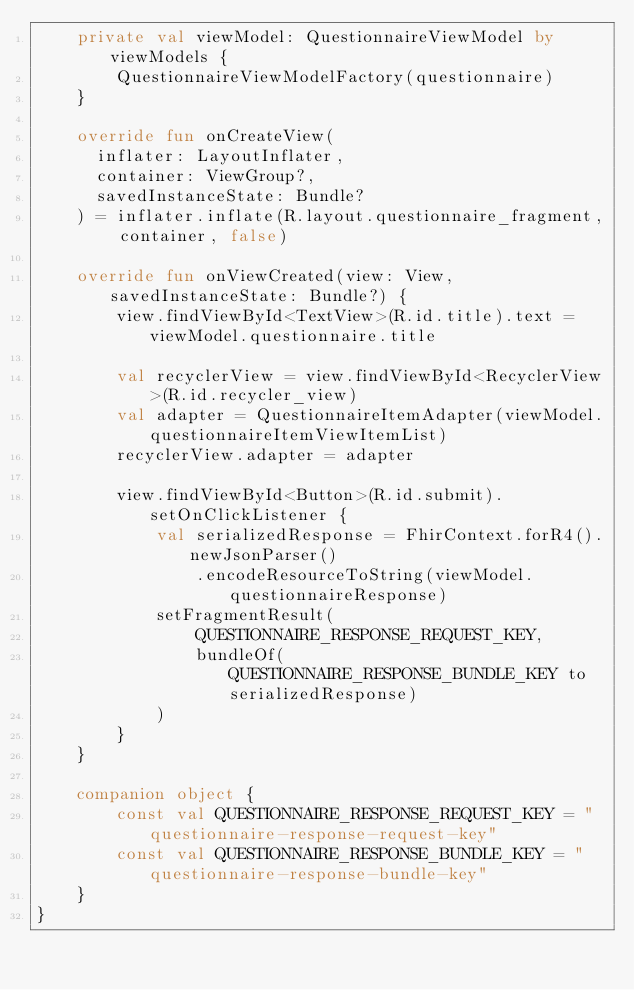Convert code to text. <code><loc_0><loc_0><loc_500><loc_500><_Kotlin_>    private val viewModel: QuestionnaireViewModel by viewModels {
        QuestionnaireViewModelFactory(questionnaire)
    }

    override fun onCreateView(
      inflater: LayoutInflater,
      container: ViewGroup?,
      savedInstanceState: Bundle?
    ) = inflater.inflate(R.layout.questionnaire_fragment, container, false)

    override fun onViewCreated(view: View, savedInstanceState: Bundle?) {
        view.findViewById<TextView>(R.id.title).text = viewModel.questionnaire.title

        val recyclerView = view.findViewById<RecyclerView>(R.id.recycler_view)
        val adapter = QuestionnaireItemAdapter(viewModel.questionnaireItemViewItemList)
        recyclerView.adapter = adapter

        view.findViewById<Button>(R.id.submit).setOnClickListener {
            val serializedResponse = FhirContext.forR4().newJsonParser()
                .encodeResourceToString(viewModel.questionnaireResponse)
            setFragmentResult(
                QUESTIONNAIRE_RESPONSE_REQUEST_KEY,
                bundleOf(QUESTIONNAIRE_RESPONSE_BUNDLE_KEY to serializedResponse)
            )
        }
    }

    companion object {
        const val QUESTIONNAIRE_RESPONSE_REQUEST_KEY = "questionnaire-response-request-key"
        const val QUESTIONNAIRE_RESPONSE_BUNDLE_KEY = "questionnaire-response-bundle-key"
    }
}
</code> 